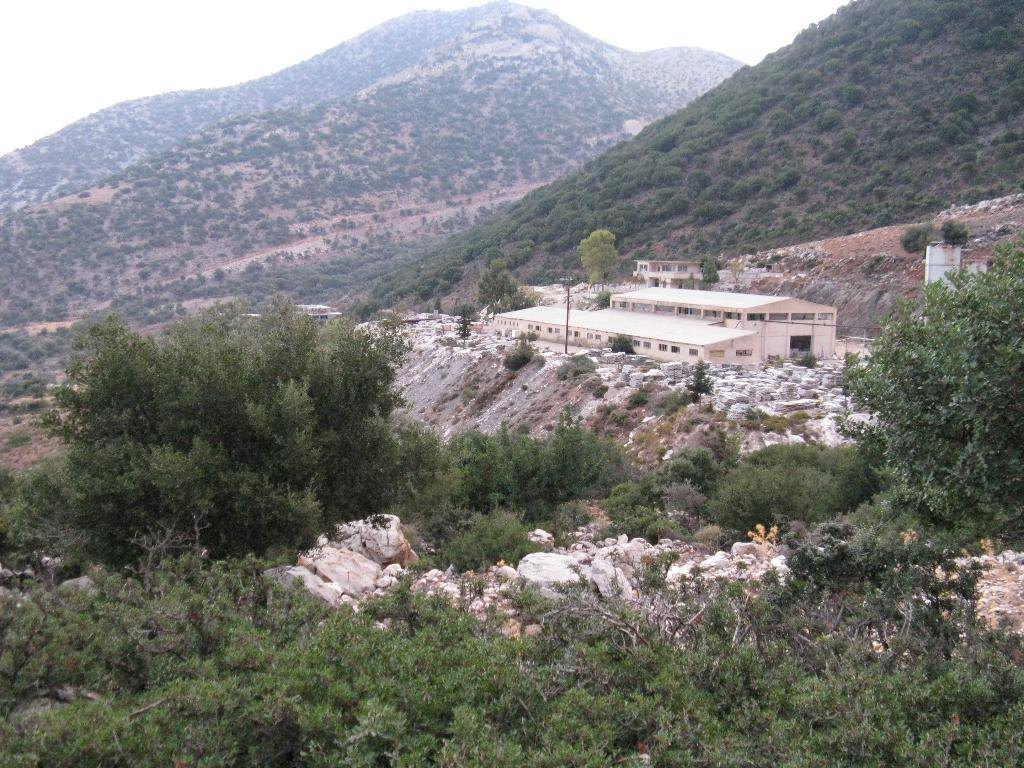What type of natural environment is depicted in the image? There are a lot of trees in the image, suggesting a forest or wooded area. What geographical features can be seen in the image? There are two mountains in the image. What structure is located between the mountains? There is a building between the mountains. How many cats are sitting on top of the building in the image? There are no cats present in the image; it features trees, mountains, and a building. What type of arithmetic problem can be solved using the number of trees in the image? There is no arithmetic problem related to the number of trees in the image, as the conversation focuses on describing the image's contents rather than performing calculations. 